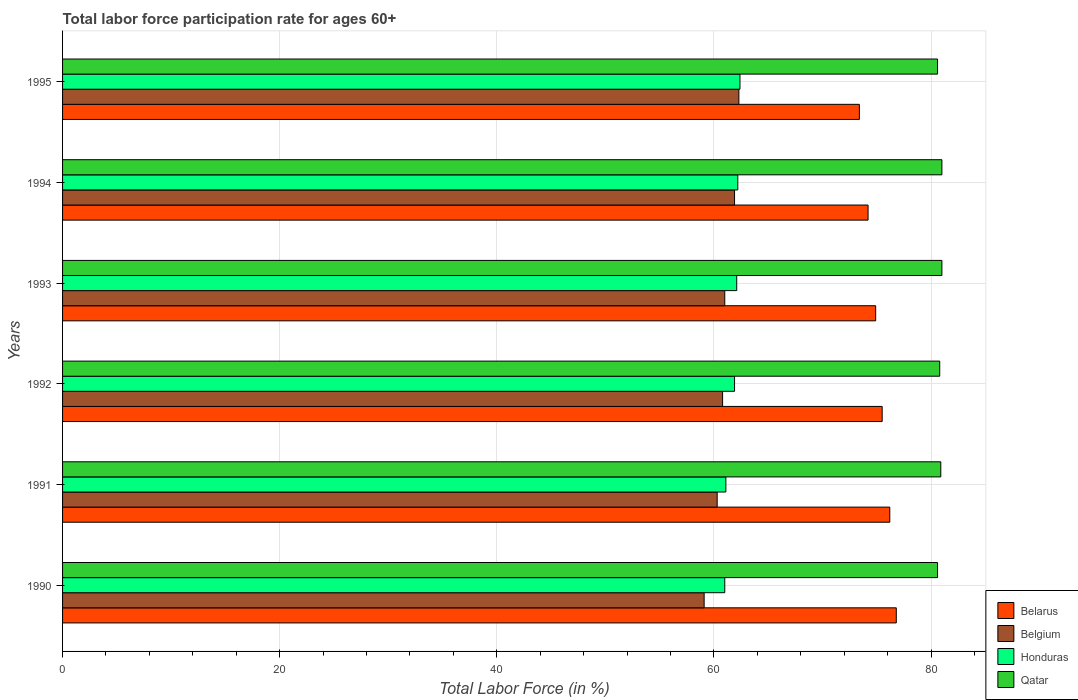How many different coloured bars are there?
Make the answer very short. 4. How many bars are there on the 1st tick from the bottom?
Offer a terse response. 4. What is the label of the 6th group of bars from the top?
Ensure brevity in your answer.  1990. In how many cases, is the number of bars for a given year not equal to the number of legend labels?
Offer a very short reply. 0. What is the labor force participation rate in Belarus in 1990?
Offer a terse response. 76.8. Across all years, what is the maximum labor force participation rate in Belarus?
Offer a very short reply. 76.8. Across all years, what is the minimum labor force participation rate in Qatar?
Give a very brief answer. 80.6. What is the total labor force participation rate in Qatar in the graph?
Give a very brief answer. 484.9. What is the difference between the labor force participation rate in Honduras in 1993 and that in 1995?
Your response must be concise. -0.3. What is the difference between the labor force participation rate in Belarus in 1992 and the labor force participation rate in Qatar in 1995?
Your answer should be very brief. -5.1. What is the average labor force participation rate in Qatar per year?
Your answer should be very brief. 80.82. In the year 1994, what is the difference between the labor force participation rate in Belgium and labor force participation rate in Belarus?
Provide a succinct answer. -12.3. What is the ratio of the labor force participation rate in Honduras in 1990 to that in 1995?
Your response must be concise. 0.98. Is the labor force participation rate in Qatar in 1993 less than that in 1995?
Provide a short and direct response. No. Is the difference between the labor force participation rate in Belgium in 1992 and 1993 greater than the difference between the labor force participation rate in Belarus in 1992 and 1993?
Provide a short and direct response. No. What is the difference between the highest and the second highest labor force participation rate in Belgium?
Your response must be concise. 0.4. What is the difference between the highest and the lowest labor force participation rate in Honduras?
Give a very brief answer. 1.4. Is it the case that in every year, the sum of the labor force participation rate in Belarus and labor force participation rate in Qatar is greater than the sum of labor force participation rate in Belgium and labor force participation rate in Honduras?
Provide a succinct answer. Yes. What does the 3rd bar from the top in 1990 represents?
Ensure brevity in your answer.  Belgium. What does the 2nd bar from the bottom in 1995 represents?
Ensure brevity in your answer.  Belgium. How many years are there in the graph?
Keep it short and to the point. 6. What is the difference between two consecutive major ticks on the X-axis?
Give a very brief answer. 20. Are the values on the major ticks of X-axis written in scientific E-notation?
Provide a succinct answer. No. Does the graph contain grids?
Your answer should be very brief. Yes. Where does the legend appear in the graph?
Your answer should be compact. Bottom right. How many legend labels are there?
Provide a short and direct response. 4. What is the title of the graph?
Make the answer very short. Total labor force participation rate for ages 60+. What is the label or title of the X-axis?
Your answer should be very brief. Total Labor Force (in %). What is the Total Labor Force (in %) in Belarus in 1990?
Keep it short and to the point. 76.8. What is the Total Labor Force (in %) of Belgium in 1990?
Provide a succinct answer. 59.1. What is the Total Labor Force (in %) in Qatar in 1990?
Keep it short and to the point. 80.6. What is the Total Labor Force (in %) of Belarus in 1991?
Provide a short and direct response. 76.2. What is the Total Labor Force (in %) of Belgium in 1991?
Ensure brevity in your answer.  60.3. What is the Total Labor Force (in %) of Honduras in 1991?
Ensure brevity in your answer.  61.1. What is the Total Labor Force (in %) in Qatar in 1991?
Provide a succinct answer. 80.9. What is the Total Labor Force (in %) in Belarus in 1992?
Your answer should be very brief. 75.5. What is the Total Labor Force (in %) of Belgium in 1992?
Your response must be concise. 60.8. What is the Total Labor Force (in %) in Honduras in 1992?
Offer a very short reply. 61.9. What is the Total Labor Force (in %) of Qatar in 1992?
Make the answer very short. 80.8. What is the Total Labor Force (in %) of Belarus in 1993?
Ensure brevity in your answer.  74.9. What is the Total Labor Force (in %) of Belgium in 1993?
Ensure brevity in your answer.  61. What is the Total Labor Force (in %) of Honduras in 1993?
Provide a succinct answer. 62.1. What is the Total Labor Force (in %) in Belarus in 1994?
Give a very brief answer. 74.2. What is the Total Labor Force (in %) in Belgium in 1994?
Offer a very short reply. 61.9. What is the Total Labor Force (in %) of Honduras in 1994?
Your answer should be compact. 62.2. What is the Total Labor Force (in %) of Qatar in 1994?
Provide a succinct answer. 81. What is the Total Labor Force (in %) of Belarus in 1995?
Keep it short and to the point. 73.4. What is the Total Labor Force (in %) in Belgium in 1995?
Ensure brevity in your answer.  62.3. What is the Total Labor Force (in %) of Honduras in 1995?
Ensure brevity in your answer.  62.4. What is the Total Labor Force (in %) in Qatar in 1995?
Keep it short and to the point. 80.6. Across all years, what is the maximum Total Labor Force (in %) of Belarus?
Your response must be concise. 76.8. Across all years, what is the maximum Total Labor Force (in %) in Belgium?
Your response must be concise. 62.3. Across all years, what is the maximum Total Labor Force (in %) of Honduras?
Your answer should be very brief. 62.4. Across all years, what is the minimum Total Labor Force (in %) in Belarus?
Offer a terse response. 73.4. Across all years, what is the minimum Total Labor Force (in %) in Belgium?
Your answer should be very brief. 59.1. Across all years, what is the minimum Total Labor Force (in %) of Qatar?
Keep it short and to the point. 80.6. What is the total Total Labor Force (in %) in Belarus in the graph?
Make the answer very short. 451. What is the total Total Labor Force (in %) in Belgium in the graph?
Make the answer very short. 365.4. What is the total Total Labor Force (in %) in Honduras in the graph?
Your answer should be very brief. 370.7. What is the total Total Labor Force (in %) of Qatar in the graph?
Provide a short and direct response. 484.9. What is the difference between the Total Labor Force (in %) in Belarus in 1990 and that in 1991?
Provide a succinct answer. 0.6. What is the difference between the Total Labor Force (in %) in Belgium in 1990 and that in 1991?
Your response must be concise. -1.2. What is the difference between the Total Labor Force (in %) in Qatar in 1990 and that in 1991?
Your answer should be compact. -0.3. What is the difference between the Total Labor Force (in %) of Belarus in 1990 and that in 1992?
Keep it short and to the point. 1.3. What is the difference between the Total Labor Force (in %) of Belarus in 1990 and that in 1993?
Your response must be concise. 1.9. What is the difference between the Total Labor Force (in %) in Honduras in 1990 and that in 1993?
Give a very brief answer. -1.1. What is the difference between the Total Labor Force (in %) of Belgium in 1990 and that in 1994?
Offer a very short reply. -2.8. What is the difference between the Total Labor Force (in %) of Honduras in 1990 and that in 1994?
Your answer should be compact. -1.2. What is the difference between the Total Labor Force (in %) in Qatar in 1990 and that in 1994?
Ensure brevity in your answer.  -0.4. What is the difference between the Total Labor Force (in %) in Honduras in 1990 and that in 1995?
Your response must be concise. -1.4. What is the difference between the Total Labor Force (in %) in Belarus in 1991 and that in 1992?
Your response must be concise. 0.7. What is the difference between the Total Labor Force (in %) of Belgium in 1991 and that in 1992?
Ensure brevity in your answer.  -0.5. What is the difference between the Total Labor Force (in %) of Honduras in 1991 and that in 1992?
Your answer should be very brief. -0.8. What is the difference between the Total Labor Force (in %) in Honduras in 1991 and that in 1993?
Keep it short and to the point. -1. What is the difference between the Total Labor Force (in %) of Qatar in 1991 and that in 1993?
Your response must be concise. -0.1. What is the difference between the Total Labor Force (in %) of Belarus in 1991 and that in 1994?
Your answer should be very brief. 2. What is the difference between the Total Labor Force (in %) of Qatar in 1991 and that in 1994?
Your response must be concise. -0.1. What is the difference between the Total Labor Force (in %) in Belarus in 1991 and that in 1995?
Your response must be concise. 2.8. What is the difference between the Total Labor Force (in %) in Honduras in 1991 and that in 1995?
Keep it short and to the point. -1.3. What is the difference between the Total Labor Force (in %) of Qatar in 1991 and that in 1995?
Keep it short and to the point. 0.3. What is the difference between the Total Labor Force (in %) in Belarus in 1992 and that in 1993?
Make the answer very short. 0.6. What is the difference between the Total Labor Force (in %) in Qatar in 1992 and that in 1993?
Provide a short and direct response. -0.2. What is the difference between the Total Labor Force (in %) in Honduras in 1992 and that in 1994?
Make the answer very short. -0.3. What is the difference between the Total Labor Force (in %) of Qatar in 1992 and that in 1994?
Your answer should be compact. -0.2. What is the difference between the Total Labor Force (in %) of Honduras in 1992 and that in 1995?
Your answer should be compact. -0.5. What is the difference between the Total Labor Force (in %) in Qatar in 1992 and that in 1995?
Offer a terse response. 0.2. What is the difference between the Total Labor Force (in %) in Qatar in 1993 and that in 1994?
Provide a succinct answer. 0. What is the difference between the Total Labor Force (in %) in Qatar in 1993 and that in 1995?
Provide a succinct answer. 0.4. What is the difference between the Total Labor Force (in %) of Belarus in 1994 and that in 1995?
Your answer should be compact. 0.8. What is the difference between the Total Labor Force (in %) of Belgium in 1994 and that in 1995?
Provide a short and direct response. -0.4. What is the difference between the Total Labor Force (in %) of Belarus in 1990 and the Total Labor Force (in %) of Qatar in 1991?
Offer a terse response. -4.1. What is the difference between the Total Labor Force (in %) of Belgium in 1990 and the Total Labor Force (in %) of Honduras in 1991?
Offer a very short reply. -2. What is the difference between the Total Labor Force (in %) of Belgium in 1990 and the Total Labor Force (in %) of Qatar in 1991?
Make the answer very short. -21.8. What is the difference between the Total Labor Force (in %) in Honduras in 1990 and the Total Labor Force (in %) in Qatar in 1991?
Make the answer very short. -19.9. What is the difference between the Total Labor Force (in %) in Belarus in 1990 and the Total Labor Force (in %) in Belgium in 1992?
Your answer should be very brief. 16. What is the difference between the Total Labor Force (in %) in Belarus in 1990 and the Total Labor Force (in %) in Honduras in 1992?
Make the answer very short. 14.9. What is the difference between the Total Labor Force (in %) of Belarus in 1990 and the Total Labor Force (in %) of Qatar in 1992?
Your answer should be compact. -4. What is the difference between the Total Labor Force (in %) in Belgium in 1990 and the Total Labor Force (in %) in Qatar in 1992?
Offer a very short reply. -21.7. What is the difference between the Total Labor Force (in %) of Honduras in 1990 and the Total Labor Force (in %) of Qatar in 1992?
Keep it short and to the point. -19.8. What is the difference between the Total Labor Force (in %) in Belarus in 1990 and the Total Labor Force (in %) in Belgium in 1993?
Provide a short and direct response. 15.8. What is the difference between the Total Labor Force (in %) in Belarus in 1990 and the Total Labor Force (in %) in Qatar in 1993?
Your response must be concise. -4.2. What is the difference between the Total Labor Force (in %) in Belgium in 1990 and the Total Labor Force (in %) in Honduras in 1993?
Ensure brevity in your answer.  -3. What is the difference between the Total Labor Force (in %) in Belgium in 1990 and the Total Labor Force (in %) in Qatar in 1993?
Give a very brief answer. -21.9. What is the difference between the Total Labor Force (in %) of Honduras in 1990 and the Total Labor Force (in %) of Qatar in 1993?
Keep it short and to the point. -20. What is the difference between the Total Labor Force (in %) of Belarus in 1990 and the Total Labor Force (in %) of Belgium in 1994?
Provide a short and direct response. 14.9. What is the difference between the Total Labor Force (in %) in Belarus in 1990 and the Total Labor Force (in %) in Honduras in 1994?
Give a very brief answer. 14.6. What is the difference between the Total Labor Force (in %) in Belarus in 1990 and the Total Labor Force (in %) in Qatar in 1994?
Make the answer very short. -4.2. What is the difference between the Total Labor Force (in %) of Belgium in 1990 and the Total Labor Force (in %) of Qatar in 1994?
Keep it short and to the point. -21.9. What is the difference between the Total Labor Force (in %) in Honduras in 1990 and the Total Labor Force (in %) in Qatar in 1994?
Ensure brevity in your answer.  -20. What is the difference between the Total Labor Force (in %) in Belgium in 1990 and the Total Labor Force (in %) in Honduras in 1995?
Your response must be concise. -3.3. What is the difference between the Total Labor Force (in %) of Belgium in 1990 and the Total Labor Force (in %) of Qatar in 1995?
Your answer should be very brief. -21.5. What is the difference between the Total Labor Force (in %) of Honduras in 1990 and the Total Labor Force (in %) of Qatar in 1995?
Ensure brevity in your answer.  -19.6. What is the difference between the Total Labor Force (in %) in Belarus in 1991 and the Total Labor Force (in %) in Belgium in 1992?
Provide a short and direct response. 15.4. What is the difference between the Total Labor Force (in %) in Belgium in 1991 and the Total Labor Force (in %) in Honduras in 1992?
Your answer should be very brief. -1.6. What is the difference between the Total Labor Force (in %) of Belgium in 1991 and the Total Labor Force (in %) of Qatar in 1992?
Your answer should be very brief. -20.5. What is the difference between the Total Labor Force (in %) in Honduras in 1991 and the Total Labor Force (in %) in Qatar in 1992?
Your answer should be very brief. -19.7. What is the difference between the Total Labor Force (in %) in Belarus in 1991 and the Total Labor Force (in %) in Honduras in 1993?
Offer a terse response. 14.1. What is the difference between the Total Labor Force (in %) in Belgium in 1991 and the Total Labor Force (in %) in Qatar in 1993?
Give a very brief answer. -20.7. What is the difference between the Total Labor Force (in %) of Honduras in 1991 and the Total Labor Force (in %) of Qatar in 1993?
Ensure brevity in your answer.  -19.9. What is the difference between the Total Labor Force (in %) in Belarus in 1991 and the Total Labor Force (in %) in Belgium in 1994?
Your answer should be very brief. 14.3. What is the difference between the Total Labor Force (in %) of Belarus in 1991 and the Total Labor Force (in %) of Honduras in 1994?
Provide a succinct answer. 14. What is the difference between the Total Labor Force (in %) of Belgium in 1991 and the Total Labor Force (in %) of Qatar in 1994?
Offer a terse response. -20.7. What is the difference between the Total Labor Force (in %) in Honduras in 1991 and the Total Labor Force (in %) in Qatar in 1994?
Your answer should be compact. -19.9. What is the difference between the Total Labor Force (in %) in Belgium in 1991 and the Total Labor Force (in %) in Honduras in 1995?
Your answer should be compact. -2.1. What is the difference between the Total Labor Force (in %) of Belgium in 1991 and the Total Labor Force (in %) of Qatar in 1995?
Provide a succinct answer. -20.3. What is the difference between the Total Labor Force (in %) of Honduras in 1991 and the Total Labor Force (in %) of Qatar in 1995?
Make the answer very short. -19.5. What is the difference between the Total Labor Force (in %) of Belarus in 1992 and the Total Labor Force (in %) of Belgium in 1993?
Give a very brief answer. 14.5. What is the difference between the Total Labor Force (in %) in Belgium in 1992 and the Total Labor Force (in %) in Qatar in 1993?
Make the answer very short. -20.2. What is the difference between the Total Labor Force (in %) in Honduras in 1992 and the Total Labor Force (in %) in Qatar in 1993?
Ensure brevity in your answer.  -19.1. What is the difference between the Total Labor Force (in %) in Belarus in 1992 and the Total Labor Force (in %) in Belgium in 1994?
Make the answer very short. 13.6. What is the difference between the Total Labor Force (in %) of Belarus in 1992 and the Total Labor Force (in %) of Honduras in 1994?
Provide a short and direct response. 13.3. What is the difference between the Total Labor Force (in %) of Belgium in 1992 and the Total Labor Force (in %) of Qatar in 1994?
Provide a short and direct response. -20.2. What is the difference between the Total Labor Force (in %) of Honduras in 1992 and the Total Labor Force (in %) of Qatar in 1994?
Make the answer very short. -19.1. What is the difference between the Total Labor Force (in %) of Belgium in 1992 and the Total Labor Force (in %) of Qatar in 1995?
Your answer should be compact. -19.8. What is the difference between the Total Labor Force (in %) in Honduras in 1992 and the Total Labor Force (in %) in Qatar in 1995?
Ensure brevity in your answer.  -18.7. What is the difference between the Total Labor Force (in %) of Belarus in 1993 and the Total Labor Force (in %) of Qatar in 1994?
Offer a very short reply. -6.1. What is the difference between the Total Labor Force (in %) in Belgium in 1993 and the Total Labor Force (in %) in Honduras in 1994?
Provide a short and direct response. -1.2. What is the difference between the Total Labor Force (in %) of Honduras in 1993 and the Total Labor Force (in %) of Qatar in 1994?
Provide a short and direct response. -18.9. What is the difference between the Total Labor Force (in %) of Belarus in 1993 and the Total Labor Force (in %) of Belgium in 1995?
Provide a short and direct response. 12.6. What is the difference between the Total Labor Force (in %) in Belarus in 1993 and the Total Labor Force (in %) in Qatar in 1995?
Keep it short and to the point. -5.7. What is the difference between the Total Labor Force (in %) of Belgium in 1993 and the Total Labor Force (in %) of Honduras in 1995?
Offer a terse response. -1.4. What is the difference between the Total Labor Force (in %) of Belgium in 1993 and the Total Labor Force (in %) of Qatar in 1995?
Provide a succinct answer. -19.6. What is the difference between the Total Labor Force (in %) of Honduras in 1993 and the Total Labor Force (in %) of Qatar in 1995?
Ensure brevity in your answer.  -18.5. What is the difference between the Total Labor Force (in %) of Belarus in 1994 and the Total Labor Force (in %) of Honduras in 1995?
Your response must be concise. 11.8. What is the difference between the Total Labor Force (in %) in Belgium in 1994 and the Total Labor Force (in %) in Qatar in 1995?
Provide a short and direct response. -18.7. What is the difference between the Total Labor Force (in %) of Honduras in 1994 and the Total Labor Force (in %) of Qatar in 1995?
Give a very brief answer. -18.4. What is the average Total Labor Force (in %) in Belarus per year?
Give a very brief answer. 75.17. What is the average Total Labor Force (in %) of Belgium per year?
Offer a very short reply. 60.9. What is the average Total Labor Force (in %) in Honduras per year?
Keep it short and to the point. 61.78. What is the average Total Labor Force (in %) of Qatar per year?
Offer a very short reply. 80.82. In the year 1990, what is the difference between the Total Labor Force (in %) in Belarus and Total Labor Force (in %) in Belgium?
Offer a terse response. 17.7. In the year 1990, what is the difference between the Total Labor Force (in %) of Belarus and Total Labor Force (in %) of Qatar?
Make the answer very short. -3.8. In the year 1990, what is the difference between the Total Labor Force (in %) in Belgium and Total Labor Force (in %) in Qatar?
Offer a very short reply. -21.5. In the year 1990, what is the difference between the Total Labor Force (in %) in Honduras and Total Labor Force (in %) in Qatar?
Your answer should be compact. -19.6. In the year 1991, what is the difference between the Total Labor Force (in %) in Belarus and Total Labor Force (in %) in Honduras?
Provide a short and direct response. 15.1. In the year 1991, what is the difference between the Total Labor Force (in %) of Belgium and Total Labor Force (in %) of Qatar?
Give a very brief answer. -20.6. In the year 1991, what is the difference between the Total Labor Force (in %) in Honduras and Total Labor Force (in %) in Qatar?
Give a very brief answer. -19.8. In the year 1992, what is the difference between the Total Labor Force (in %) of Belarus and Total Labor Force (in %) of Belgium?
Give a very brief answer. 14.7. In the year 1992, what is the difference between the Total Labor Force (in %) of Belarus and Total Labor Force (in %) of Honduras?
Keep it short and to the point. 13.6. In the year 1992, what is the difference between the Total Labor Force (in %) in Belarus and Total Labor Force (in %) in Qatar?
Offer a very short reply. -5.3. In the year 1992, what is the difference between the Total Labor Force (in %) in Belgium and Total Labor Force (in %) in Honduras?
Give a very brief answer. -1.1. In the year 1992, what is the difference between the Total Labor Force (in %) of Honduras and Total Labor Force (in %) of Qatar?
Provide a short and direct response. -18.9. In the year 1993, what is the difference between the Total Labor Force (in %) of Belarus and Total Labor Force (in %) of Honduras?
Your response must be concise. 12.8. In the year 1993, what is the difference between the Total Labor Force (in %) in Belarus and Total Labor Force (in %) in Qatar?
Offer a very short reply. -6.1. In the year 1993, what is the difference between the Total Labor Force (in %) in Belgium and Total Labor Force (in %) in Qatar?
Ensure brevity in your answer.  -20. In the year 1993, what is the difference between the Total Labor Force (in %) of Honduras and Total Labor Force (in %) of Qatar?
Ensure brevity in your answer.  -18.9. In the year 1994, what is the difference between the Total Labor Force (in %) in Belarus and Total Labor Force (in %) in Belgium?
Provide a succinct answer. 12.3. In the year 1994, what is the difference between the Total Labor Force (in %) of Belarus and Total Labor Force (in %) of Qatar?
Ensure brevity in your answer.  -6.8. In the year 1994, what is the difference between the Total Labor Force (in %) of Belgium and Total Labor Force (in %) of Honduras?
Provide a short and direct response. -0.3. In the year 1994, what is the difference between the Total Labor Force (in %) of Belgium and Total Labor Force (in %) of Qatar?
Give a very brief answer. -19.1. In the year 1994, what is the difference between the Total Labor Force (in %) of Honduras and Total Labor Force (in %) of Qatar?
Your answer should be compact. -18.8. In the year 1995, what is the difference between the Total Labor Force (in %) of Belarus and Total Labor Force (in %) of Belgium?
Ensure brevity in your answer.  11.1. In the year 1995, what is the difference between the Total Labor Force (in %) in Belarus and Total Labor Force (in %) in Honduras?
Offer a very short reply. 11. In the year 1995, what is the difference between the Total Labor Force (in %) in Belarus and Total Labor Force (in %) in Qatar?
Your answer should be compact. -7.2. In the year 1995, what is the difference between the Total Labor Force (in %) in Belgium and Total Labor Force (in %) in Qatar?
Offer a very short reply. -18.3. In the year 1995, what is the difference between the Total Labor Force (in %) of Honduras and Total Labor Force (in %) of Qatar?
Your answer should be very brief. -18.2. What is the ratio of the Total Labor Force (in %) in Belarus in 1990 to that in 1991?
Offer a terse response. 1.01. What is the ratio of the Total Labor Force (in %) of Belgium in 1990 to that in 1991?
Offer a very short reply. 0.98. What is the ratio of the Total Labor Force (in %) in Honduras in 1990 to that in 1991?
Keep it short and to the point. 1. What is the ratio of the Total Labor Force (in %) in Belarus in 1990 to that in 1992?
Keep it short and to the point. 1.02. What is the ratio of the Total Labor Force (in %) of Honduras in 1990 to that in 1992?
Your answer should be very brief. 0.99. What is the ratio of the Total Labor Force (in %) in Belarus in 1990 to that in 1993?
Your answer should be very brief. 1.03. What is the ratio of the Total Labor Force (in %) of Belgium in 1990 to that in 1993?
Provide a succinct answer. 0.97. What is the ratio of the Total Labor Force (in %) of Honduras in 1990 to that in 1993?
Keep it short and to the point. 0.98. What is the ratio of the Total Labor Force (in %) in Belarus in 1990 to that in 1994?
Ensure brevity in your answer.  1.03. What is the ratio of the Total Labor Force (in %) of Belgium in 1990 to that in 1994?
Provide a short and direct response. 0.95. What is the ratio of the Total Labor Force (in %) in Honduras in 1990 to that in 1994?
Your answer should be very brief. 0.98. What is the ratio of the Total Labor Force (in %) of Qatar in 1990 to that in 1994?
Provide a succinct answer. 1. What is the ratio of the Total Labor Force (in %) in Belarus in 1990 to that in 1995?
Your answer should be compact. 1.05. What is the ratio of the Total Labor Force (in %) of Belgium in 1990 to that in 1995?
Give a very brief answer. 0.95. What is the ratio of the Total Labor Force (in %) in Honduras in 1990 to that in 1995?
Make the answer very short. 0.98. What is the ratio of the Total Labor Force (in %) of Qatar in 1990 to that in 1995?
Ensure brevity in your answer.  1. What is the ratio of the Total Labor Force (in %) in Belarus in 1991 to that in 1992?
Provide a succinct answer. 1.01. What is the ratio of the Total Labor Force (in %) of Belgium in 1991 to that in 1992?
Offer a terse response. 0.99. What is the ratio of the Total Labor Force (in %) of Honduras in 1991 to that in 1992?
Your answer should be compact. 0.99. What is the ratio of the Total Labor Force (in %) of Belarus in 1991 to that in 1993?
Ensure brevity in your answer.  1.02. What is the ratio of the Total Labor Force (in %) of Honduras in 1991 to that in 1993?
Provide a succinct answer. 0.98. What is the ratio of the Total Labor Force (in %) of Belgium in 1991 to that in 1994?
Provide a short and direct response. 0.97. What is the ratio of the Total Labor Force (in %) in Honduras in 1991 to that in 1994?
Offer a very short reply. 0.98. What is the ratio of the Total Labor Force (in %) in Belarus in 1991 to that in 1995?
Ensure brevity in your answer.  1.04. What is the ratio of the Total Labor Force (in %) in Belgium in 1991 to that in 1995?
Offer a very short reply. 0.97. What is the ratio of the Total Labor Force (in %) of Honduras in 1991 to that in 1995?
Your answer should be very brief. 0.98. What is the ratio of the Total Labor Force (in %) in Qatar in 1991 to that in 1995?
Provide a short and direct response. 1. What is the ratio of the Total Labor Force (in %) in Belarus in 1992 to that in 1993?
Your answer should be very brief. 1.01. What is the ratio of the Total Labor Force (in %) in Belgium in 1992 to that in 1993?
Your answer should be very brief. 1. What is the ratio of the Total Labor Force (in %) in Belarus in 1992 to that in 1994?
Make the answer very short. 1.02. What is the ratio of the Total Labor Force (in %) of Belgium in 1992 to that in 1994?
Provide a short and direct response. 0.98. What is the ratio of the Total Labor Force (in %) in Qatar in 1992 to that in 1994?
Provide a succinct answer. 1. What is the ratio of the Total Labor Force (in %) of Belarus in 1992 to that in 1995?
Offer a terse response. 1.03. What is the ratio of the Total Labor Force (in %) in Belgium in 1992 to that in 1995?
Provide a succinct answer. 0.98. What is the ratio of the Total Labor Force (in %) in Qatar in 1992 to that in 1995?
Offer a very short reply. 1. What is the ratio of the Total Labor Force (in %) of Belarus in 1993 to that in 1994?
Keep it short and to the point. 1.01. What is the ratio of the Total Labor Force (in %) in Belgium in 1993 to that in 1994?
Your response must be concise. 0.99. What is the ratio of the Total Labor Force (in %) in Belarus in 1993 to that in 1995?
Your response must be concise. 1.02. What is the ratio of the Total Labor Force (in %) of Belgium in 1993 to that in 1995?
Make the answer very short. 0.98. What is the ratio of the Total Labor Force (in %) of Honduras in 1993 to that in 1995?
Keep it short and to the point. 1. What is the ratio of the Total Labor Force (in %) of Belarus in 1994 to that in 1995?
Your answer should be compact. 1.01. What is the ratio of the Total Labor Force (in %) in Belgium in 1994 to that in 1995?
Keep it short and to the point. 0.99. What is the difference between the highest and the second highest Total Labor Force (in %) in Belgium?
Keep it short and to the point. 0.4. What is the difference between the highest and the second highest Total Labor Force (in %) in Honduras?
Ensure brevity in your answer.  0.2. What is the difference between the highest and the lowest Total Labor Force (in %) of Belarus?
Your answer should be very brief. 3.4. What is the difference between the highest and the lowest Total Labor Force (in %) of Belgium?
Provide a short and direct response. 3.2. 